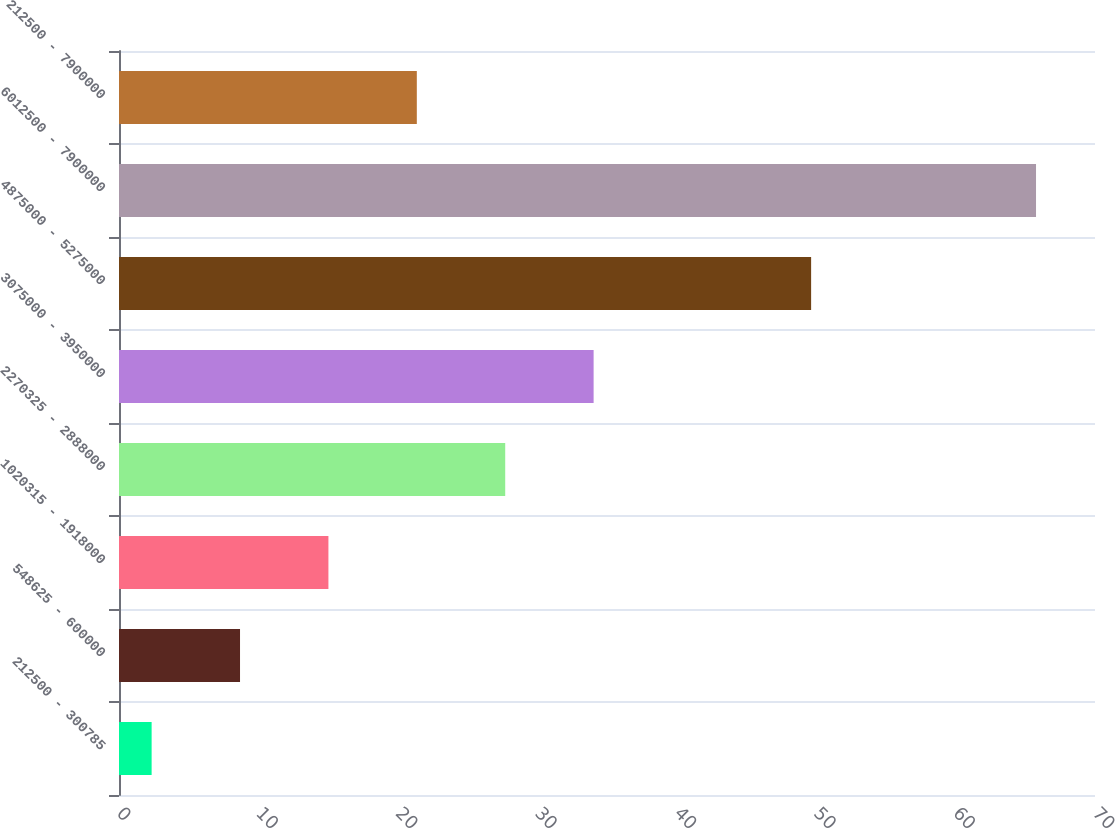Convert chart to OTSL. <chart><loc_0><loc_0><loc_500><loc_500><bar_chart><fcel>212500 - 300785<fcel>548625 - 600000<fcel>1020315 - 1918000<fcel>2270325 - 2888000<fcel>3075000 - 3950000<fcel>4875000 - 5275000<fcel>6012500 - 7900000<fcel>212500 - 7900000<nl><fcel>2.34<fcel>8.68<fcel>15.02<fcel>27.7<fcel>34.04<fcel>49.64<fcel>65.77<fcel>21.36<nl></chart> 